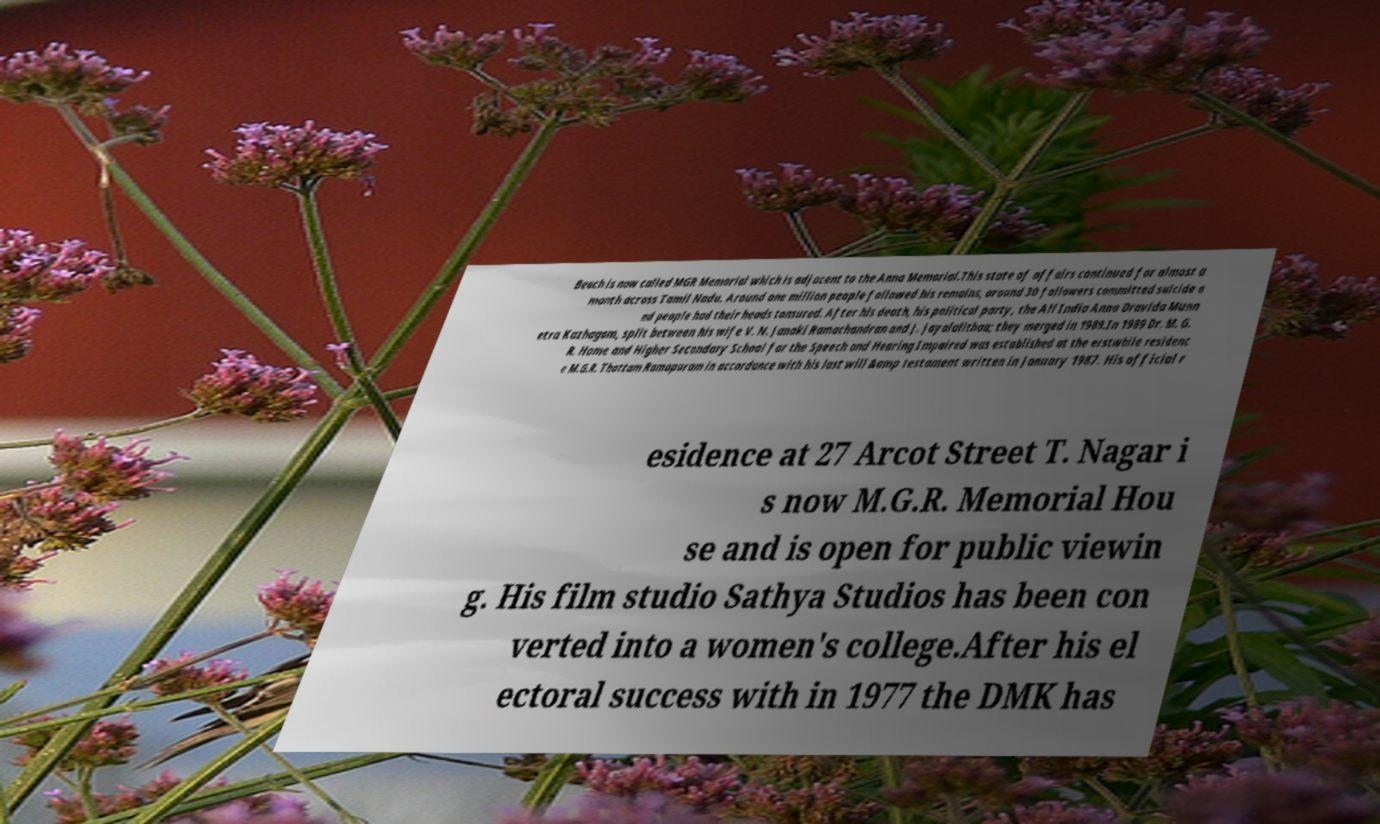Please identify and transcribe the text found in this image. Beach is now called MGR Memorial which is adjacent to the Anna Memorial.This state of affairs continued for almost a month across Tamil Nadu. Around one million people followed his remains, around 30 followers committed suicide a nd people had their heads tonsured. After his death, his political party, the All India Anna Dravida Munn etra Kazhagam, split between his wife V. N. Janaki Ramachandran and J. Jayalalithaa; they merged in 1989.In 1989 Dr. M. G. R. Home and Higher Secondary School for the Speech and Hearing Impaired was established at the erstwhile residenc e M.G.R. Thottam Ramapuram in accordance with his last will &amp testament written in January 1987. His official r esidence at 27 Arcot Street T. Nagar i s now M.G.R. Memorial Hou se and is open for public viewin g. His film studio Sathya Studios has been con verted into a women's college.After his el ectoral success with in 1977 the DMK has 